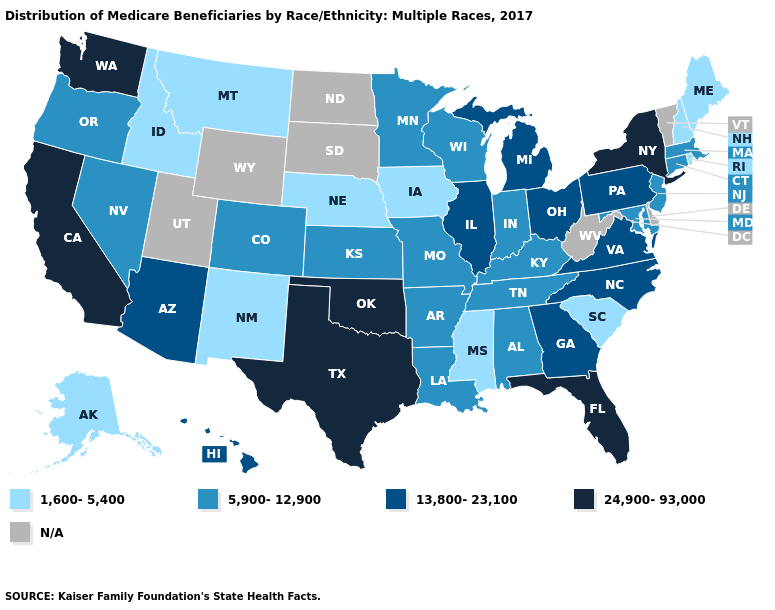What is the highest value in the USA?
Write a very short answer. 24,900-93,000. Name the states that have a value in the range 13,800-23,100?
Be succinct. Arizona, Georgia, Hawaii, Illinois, Michigan, North Carolina, Ohio, Pennsylvania, Virginia. Name the states that have a value in the range 1,600-5,400?
Write a very short answer. Alaska, Idaho, Iowa, Maine, Mississippi, Montana, Nebraska, New Hampshire, New Mexico, Rhode Island, South Carolina. What is the lowest value in the USA?
Write a very short answer. 1,600-5,400. Among the states that border Washington , which have the lowest value?
Quick response, please. Idaho. What is the value of Mississippi?
Concise answer only. 1,600-5,400. Which states have the lowest value in the Northeast?
Short answer required. Maine, New Hampshire, Rhode Island. Does Wisconsin have the highest value in the MidWest?
Short answer required. No. Which states have the lowest value in the Northeast?
Short answer required. Maine, New Hampshire, Rhode Island. Name the states that have a value in the range 1,600-5,400?
Give a very brief answer. Alaska, Idaho, Iowa, Maine, Mississippi, Montana, Nebraska, New Hampshire, New Mexico, Rhode Island, South Carolina. What is the highest value in the West ?
Give a very brief answer. 24,900-93,000. 